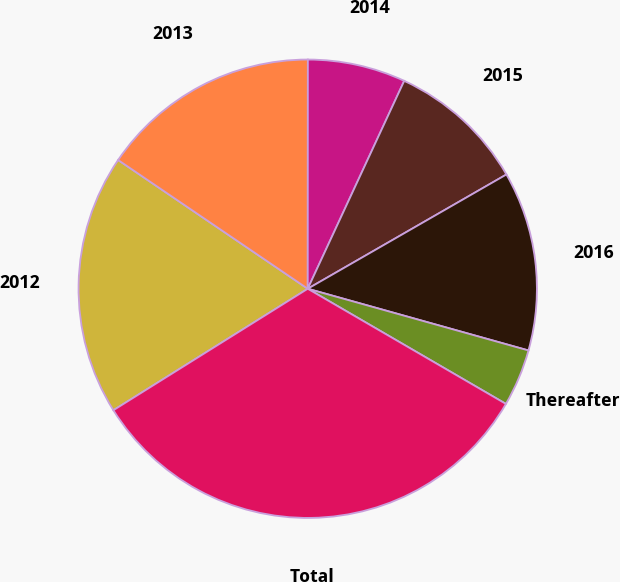Convert chart to OTSL. <chart><loc_0><loc_0><loc_500><loc_500><pie_chart><fcel>2012<fcel>2013<fcel>2014<fcel>2015<fcel>2016<fcel>Thereafter<fcel>Total<nl><fcel>18.39%<fcel>15.52%<fcel>6.91%<fcel>9.78%<fcel>12.65%<fcel>4.04%<fcel>32.74%<nl></chart> 